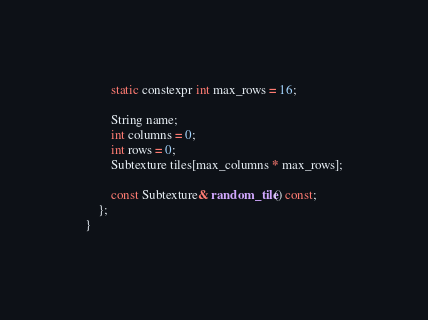Convert code to text. <code><loc_0><loc_0><loc_500><loc_500><_C_>		static constexpr int max_rows = 16;

		String name;
		int columns = 0;
		int rows = 0;
		Subtexture tiles[max_columns * max_rows];

		const Subtexture& random_tile() const;
	};
}</code> 